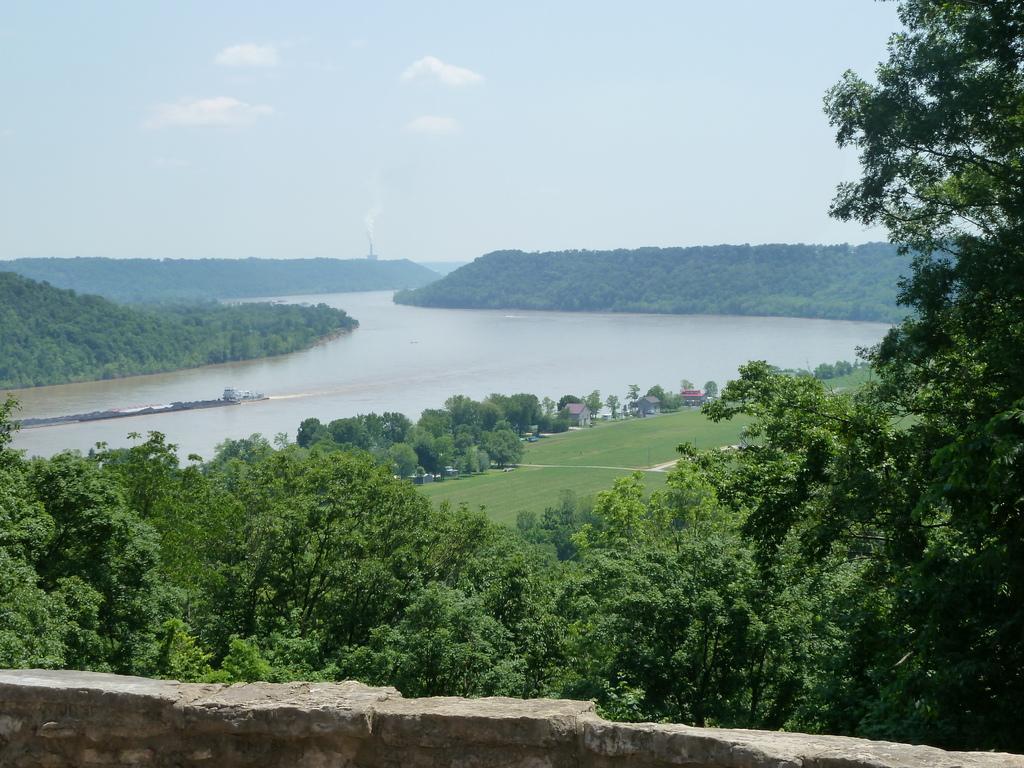Can you describe this image briefly? In this image we can see trees, grass, buildings and water body. At the bottom of the image, we can see a boundary wall. At the top of the image, we can see the sky with clouds. 